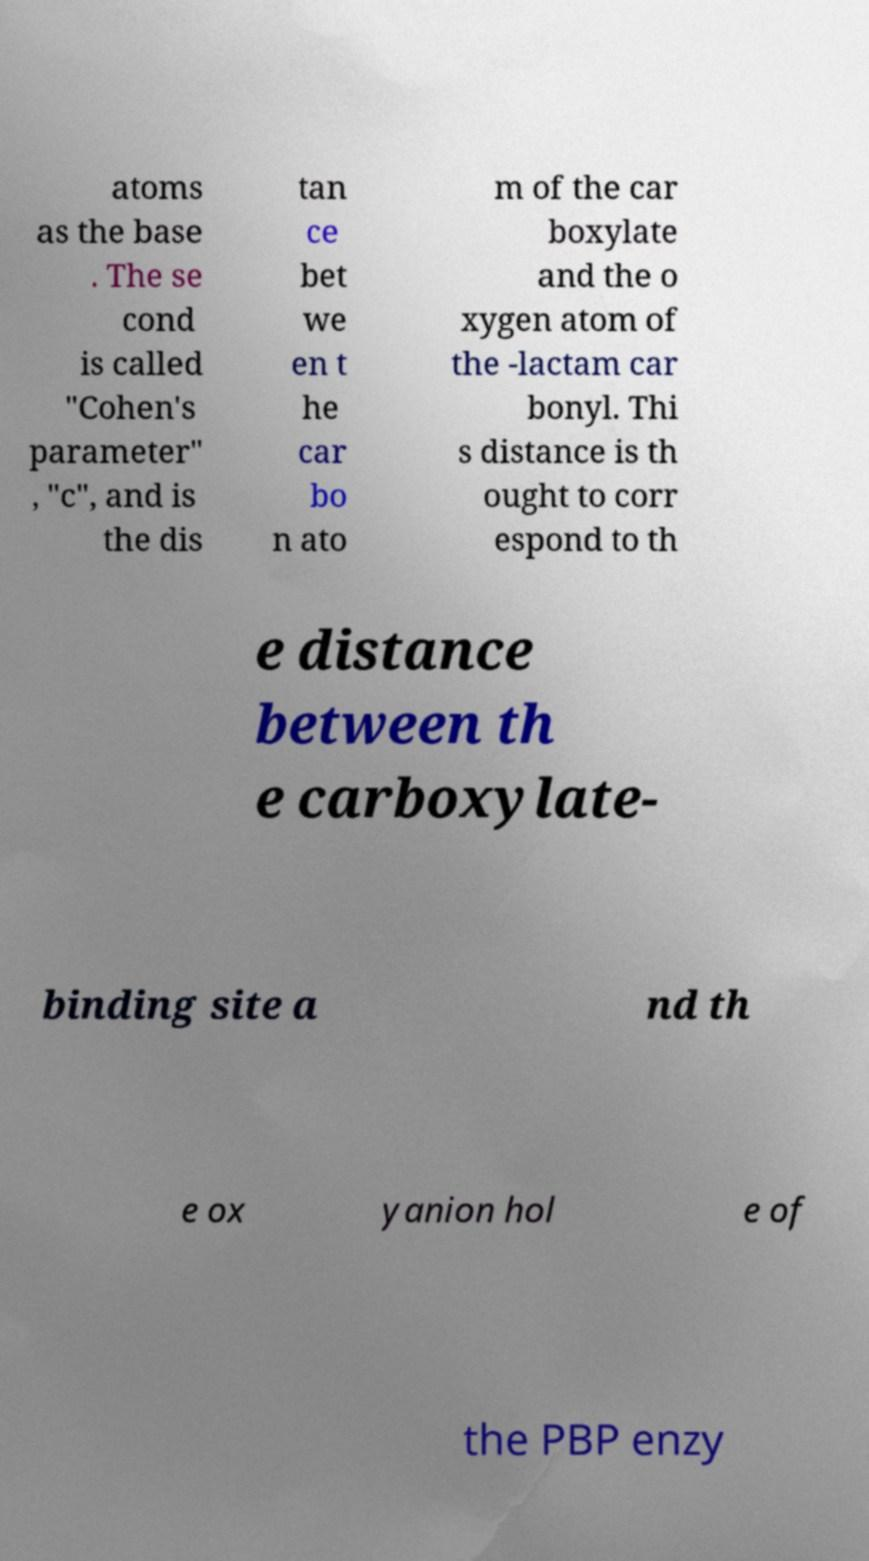Please read and relay the text visible in this image. What does it say? atoms as the base . The se cond is called "Cohen's parameter" , "c", and is the dis tan ce bet we en t he car bo n ato m of the car boxylate and the o xygen atom of the -lactam car bonyl. Thi s distance is th ought to corr espond to th e distance between th e carboxylate- binding site a nd th e ox yanion hol e of the PBP enzy 